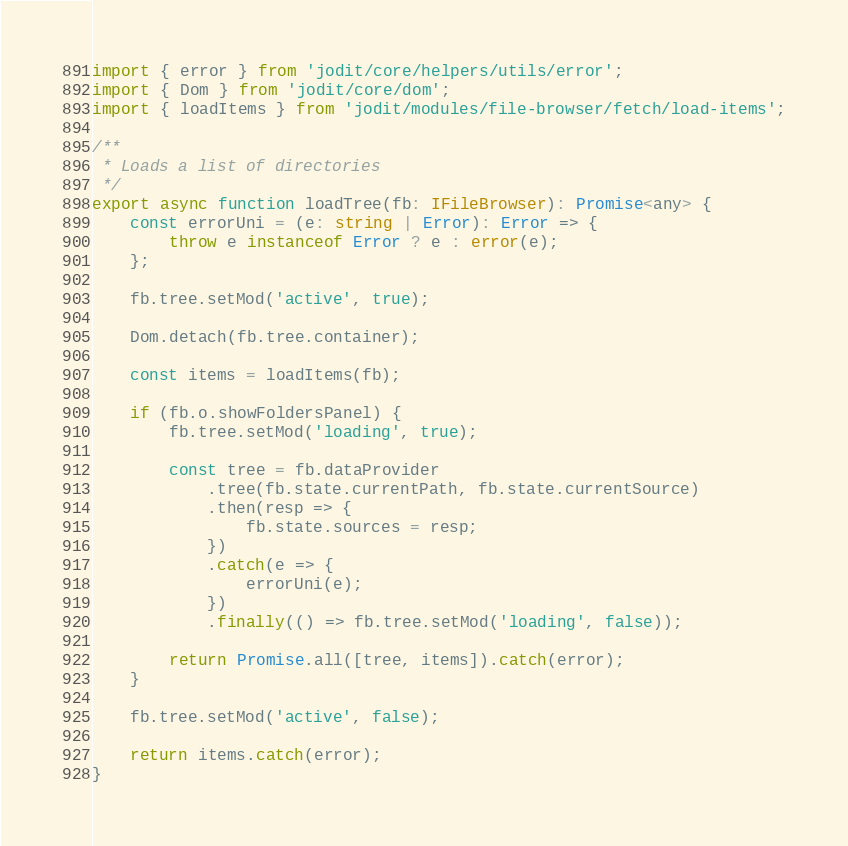Convert code to text. <code><loc_0><loc_0><loc_500><loc_500><_TypeScript_>import { error } from 'jodit/core/helpers/utils/error';
import { Dom } from 'jodit/core/dom';
import { loadItems } from 'jodit/modules/file-browser/fetch/load-items';

/**
 * Loads a list of directories
 */
export async function loadTree(fb: IFileBrowser): Promise<any> {
	const errorUni = (e: string | Error): Error => {
		throw e instanceof Error ? e : error(e);
	};

	fb.tree.setMod('active', true);

	Dom.detach(fb.tree.container);

	const items = loadItems(fb);

	if (fb.o.showFoldersPanel) {
		fb.tree.setMod('loading', true);

		const tree = fb.dataProvider
			.tree(fb.state.currentPath, fb.state.currentSource)
			.then(resp => {
				fb.state.sources = resp;
			})
			.catch(e => {
				errorUni(e);
			})
			.finally(() => fb.tree.setMod('loading', false));

		return Promise.all([tree, items]).catch(error);
	}

	fb.tree.setMod('active', false);

	return items.catch(error);
}
</code> 